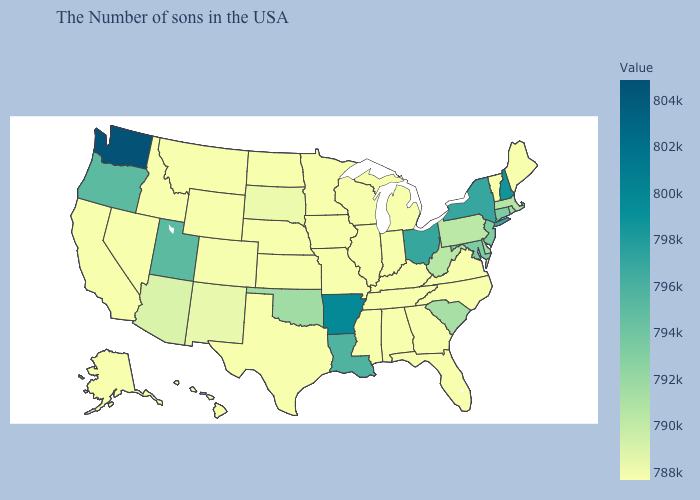Does Massachusetts have the highest value in the Northeast?
Give a very brief answer. No. Which states have the lowest value in the South?
Short answer required. Virginia, North Carolina, Florida, Georgia, Kentucky, Alabama, Tennessee, Mississippi, Texas. Among the states that border New York , which have the lowest value?
Answer briefly. Vermont. Does Connecticut have the lowest value in the Northeast?
Be succinct. No. Does Washington have the highest value in the USA?
Short answer required. Yes. Which states have the lowest value in the USA?
Short answer required. Maine, Vermont, Virginia, North Carolina, Florida, Georgia, Michigan, Kentucky, Indiana, Alabama, Tennessee, Wisconsin, Illinois, Mississippi, Missouri, Minnesota, Iowa, Kansas, Nebraska, Texas, North Dakota, Wyoming, Montana, Idaho, Nevada, California, Alaska, Hawaii. Does Florida have the lowest value in the USA?
Short answer required. Yes. 